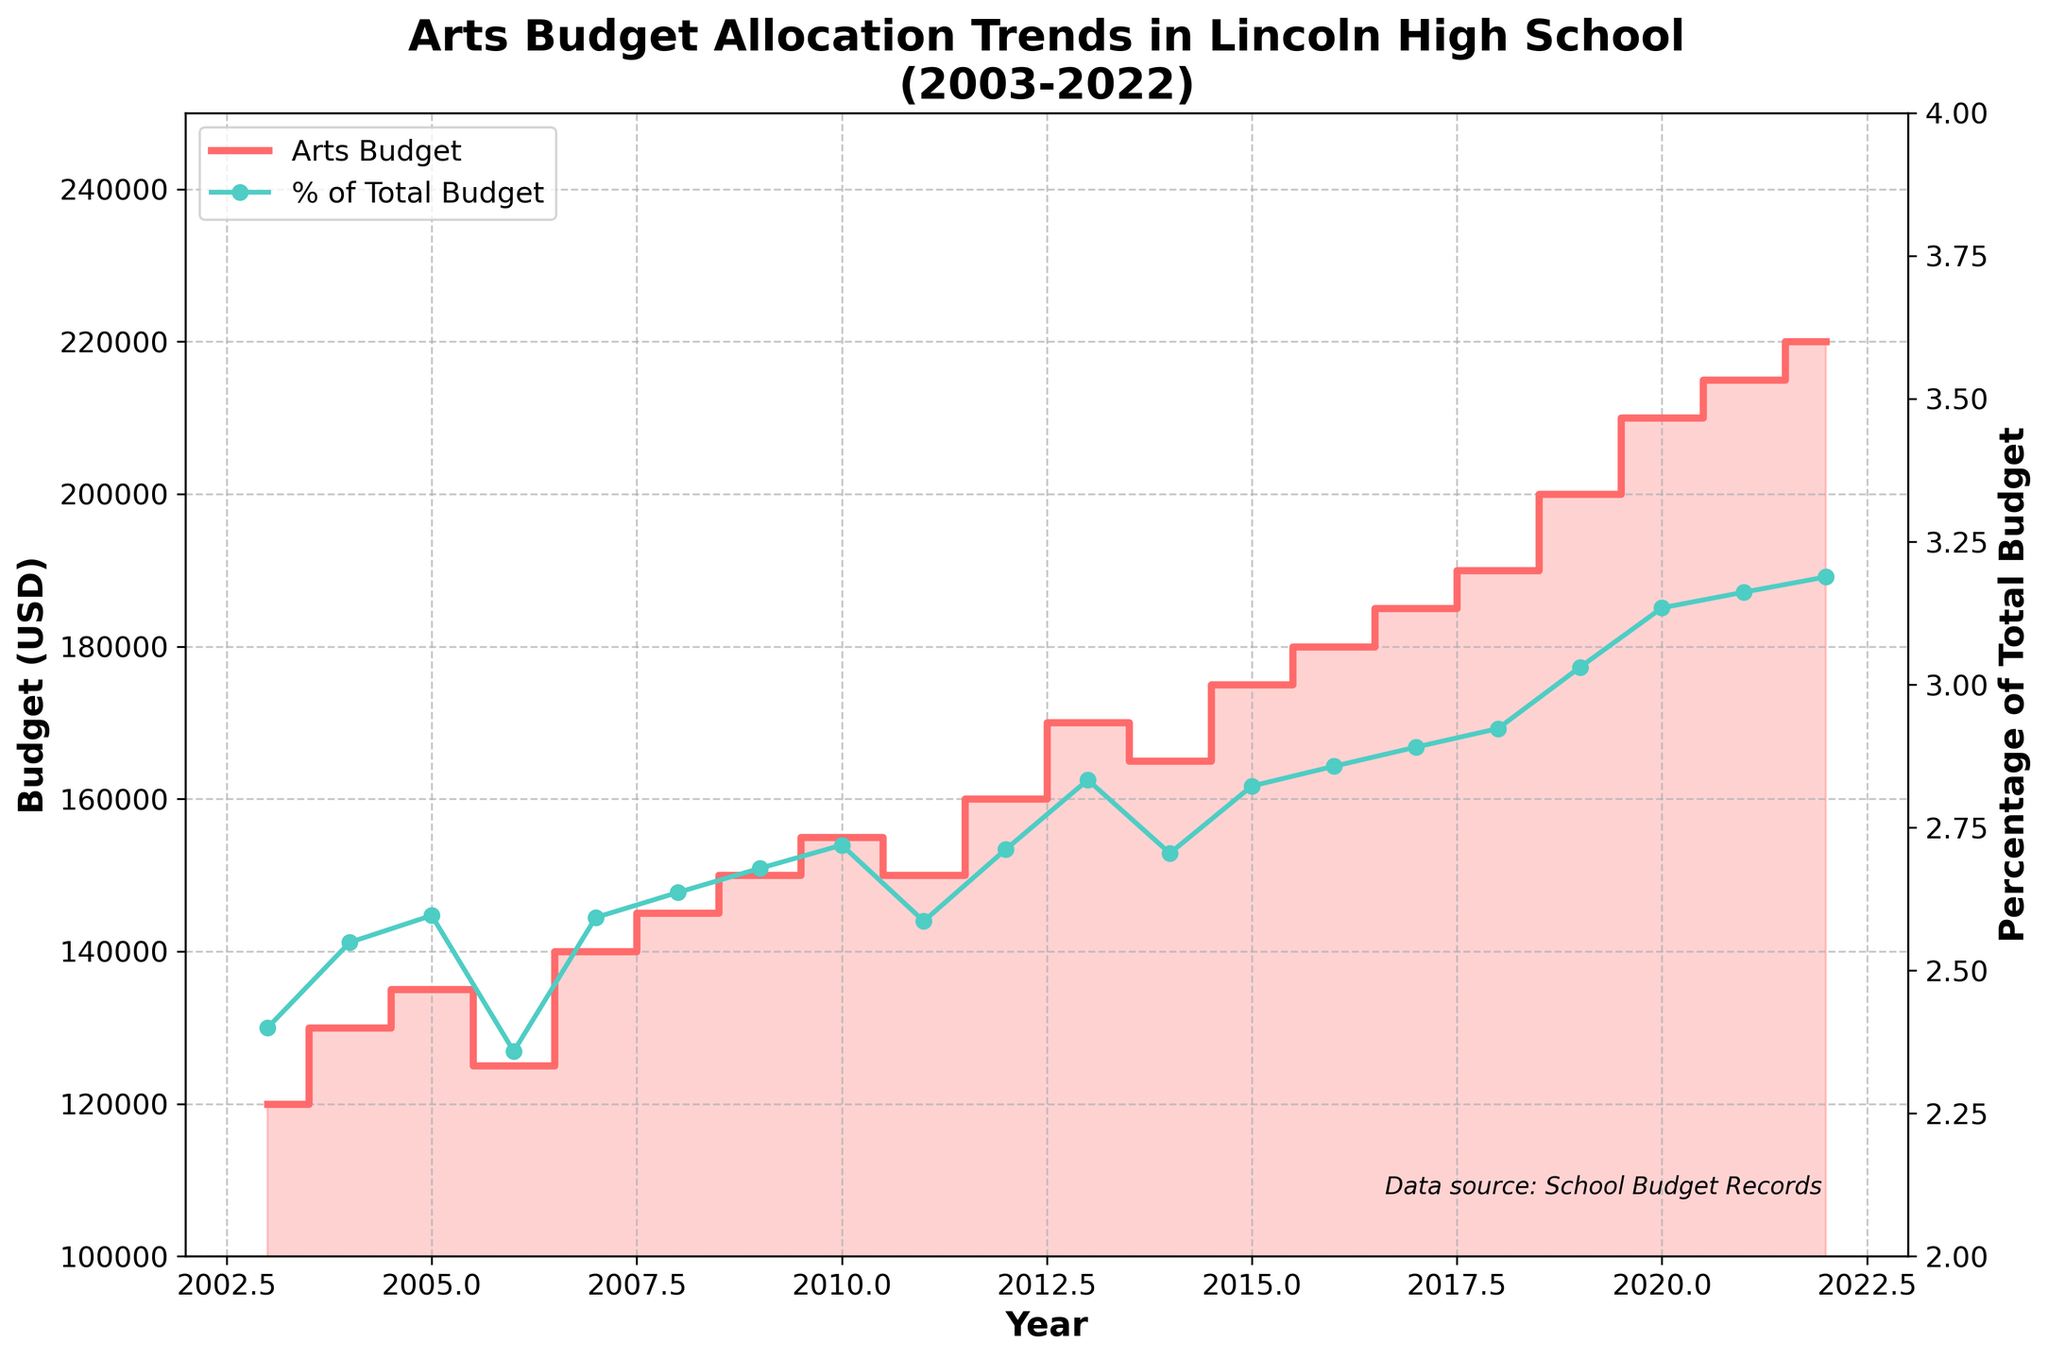What is the title of the figure? The title is usually displayed at the top of the figure. In this case, it reads 'Arts Budget Allocation Trends in Lincoln High School (2003-2022)'.
Answer: Arts Budget Allocation Trends in Lincoln High School (2003-2022) What is the specific color used for the Arts Budget line in the step plot? The Arts Budget line is represented with a red color in the step plot.
Answer: Red How many years of budget data are displayed in the figure? The figure represents data from the year 2003 to the year 2022, which is a total of 20 years.
Answer: 20 What are the minimum and maximum values of the Arts Budget in the given period? The minimum Arts Budget can be observed at the lowest point, which is $120,000. The maximum can be seen at the highest point, which is $220,000.
Answer: $120,000 and $220,000 What is the general trend of the Arts Budget allocation over the past 20 years? The general trend of the Arts Budget allocation is increasing over the 20-year period as seen from the step plot ascending overall.
Answer: Increasing What was the percentage of the total budget allocated to the arts in 2020? First, locate the year 2020 on the x-axis, find the corresponding arts budget, which is $210,000, and the total budget, which is $6,700,000. Then calculate the percentage: (210,000 / 6,700,000) * 100 ≈ 3.13%.
Answer: 3.13% Which year experienced the highest increase in the Arts Budget compared to the previous year? To find this, look at the step increments and identify the largest jump. The biggest increase occurred from 2002 to 2023 where the budget rose from $210,000 to $220,000, a $10,000 increase.
Answer: 2022 How did the Arts Budget percentage of the total school budget change from 2011 to 2012? In 2011, the Arts Budget was $150,000, and the total budget was $5,800,000, making the percentage (150,000 / 5,800,000) * 100 ≈ 2.59%. In 2012, the Arts Budget was $160,000 and the total budget was $5,900,000, making the percentage (160,000 / 5,900,000) * 100 ≈ 2.71%. Therefore, the percentage increased by 0.12%.
Answer: Increased by 0.12% What was the average Arts Budget allocation over the span of the figure? Sum all the Arts Budget yearly values from 2003 to 2022 and divide by 20 years. (120000+130000+135000+125000+140000+145000+150000+155000+150000+160000+170000+165000+175000+180000+185000+190000+200000+210000+215000+220000) / 20 = 165250.
Answer: $165,250 